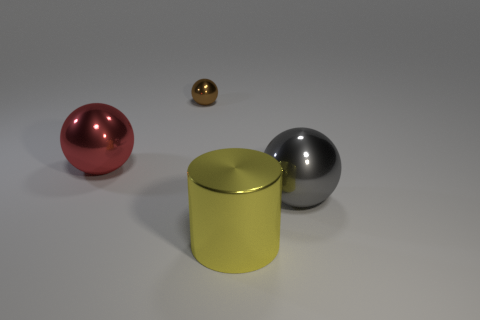Subtract all purple cylinders. Subtract all gray cubes. How many cylinders are left? 1 Add 3 large yellow cylinders. How many objects exist? 7 Subtract all cylinders. How many objects are left? 3 Subtract 0 red cylinders. How many objects are left? 4 Subtract all metallic spheres. Subtract all brown metallic spheres. How many objects are left? 0 Add 3 gray shiny objects. How many gray shiny objects are left? 4 Add 1 brown shiny blocks. How many brown shiny blocks exist? 1 